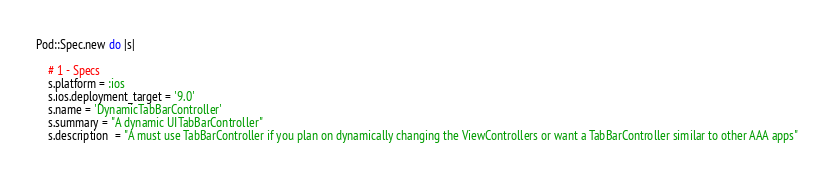Convert code to text. <code><loc_0><loc_0><loc_500><loc_500><_Ruby_>
Pod::Spec.new do |s|

    # 1 - Specs
    s.platform = :ios
    s.ios.deployment_target = '9.0'
    s.name = 'DynamicTabBarController'
    s.summary = "A dynamic UITabBarController"
    s.description  = "A must use TabBarController if you plan on dynamically changing the ViewControllers or want a TabBarController similar to other AAA apps"</code> 